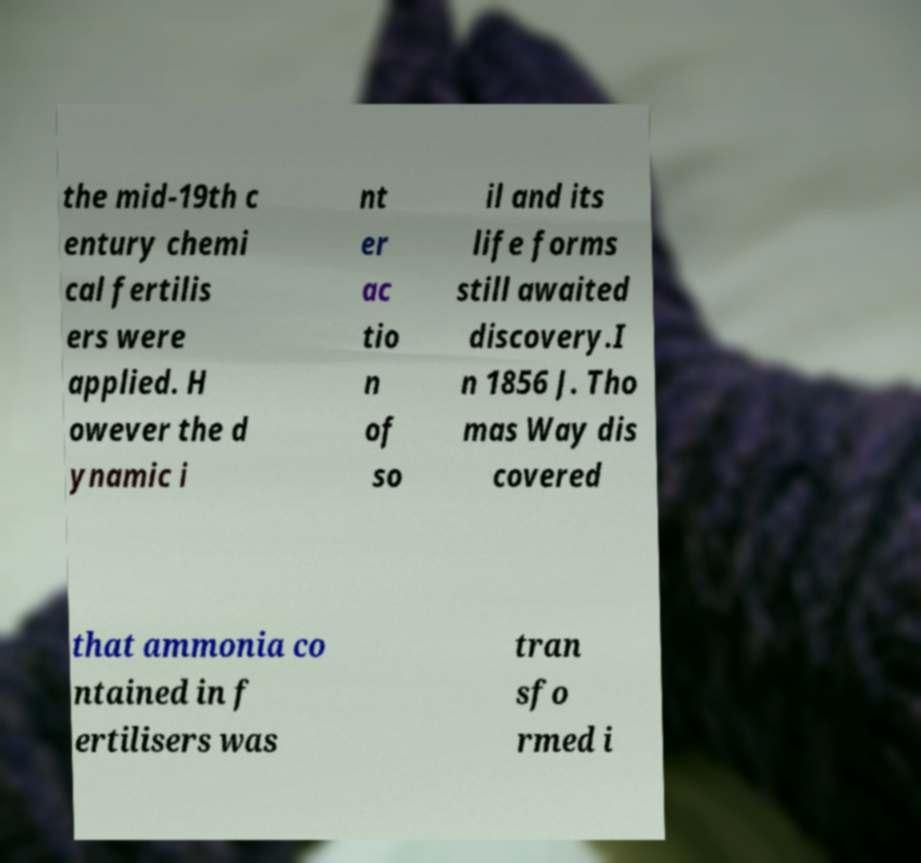Please identify and transcribe the text found in this image. the mid-19th c entury chemi cal fertilis ers were applied. H owever the d ynamic i nt er ac tio n of so il and its life forms still awaited discovery.I n 1856 J. Tho mas Way dis covered that ammonia co ntained in f ertilisers was tran sfo rmed i 